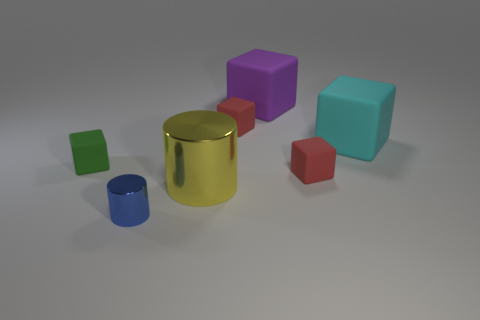How big is the thing that is to the right of the large purple cube and in front of the small green object?
Ensure brevity in your answer.  Small. There is a small object that is in front of the yellow metal object; does it have the same shape as the yellow shiny thing?
Keep it short and to the point. Yes. How many things are either blocks right of the small blue metallic thing or tiny yellow rubber cylinders?
Offer a very short reply. 4. Is there a small blue object that has the same shape as the big metallic thing?
Provide a succinct answer. Yes. There is a yellow shiny object that is the same size as the purple thing; what is its shape?
Keep it short and to the point. Cylinder. There is a red rubber thing behind the red object in front of the red thing behind the small green matte block; what shape is it?
Keep it short and to the point. Cube. Does the green thing have the same shape as the big cyan thing behind the blue cylinder?
Your answer should be very brief. Yes. What number of tiny things are cylinders or yellow metal objects?
Provide a succinct answer. 1. Are there any purple matte blocks of the same size as the yellow object?
Provide a short and direct response. Yes. The shiny object that is behind the metal thing that is left of the metallic thing that is on the right side of the small metallic cylinder is what color?
Your response must be concise. Yellow. 